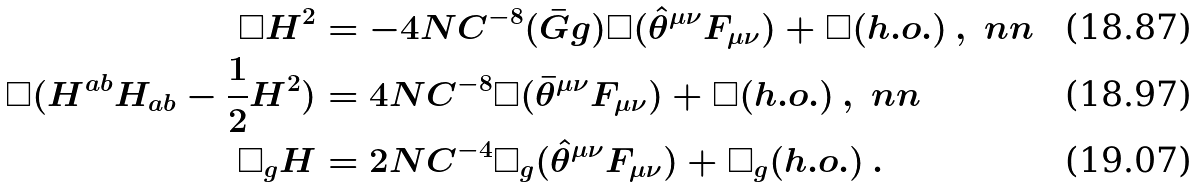<formula> <loc_0><loc_0><loc_500><loc_500>\Box H ^ { 2 } & = - 4 \L N C ^ { - 8 } ( \bar { G } g ) \Box ( \hat { \theta } ^ { \mu \nu } F _ { \mu \nu } ) + \Box ( h . o . ) \, , \ n n \\ \Box ( H ^ { a b } H _ { a b } - \frac { 1 } { 2 } H ^ { 2 } ) & = 4 \L N C ^ { - 8 } \Box ( \bar { \theta } ^ { \mu \nu } F _ { \mu \nu } ) + \Box ( h . o . ) \, , \ n n \\ \Box _ { g } H & = 2 \L N C ^ { - 4 } \Box _ { g } ( \hat { \theta } ^ { \mu \nu } F _ { \mu \nu } ) + \Box _ { g } ( h . o . ) \, .</formula> 